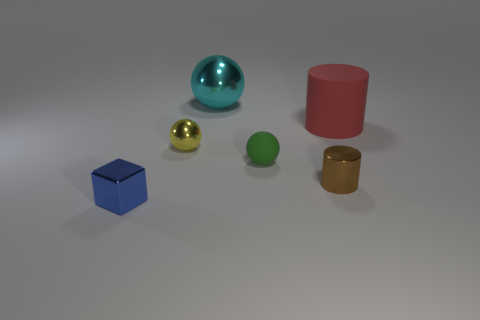What shape is the other rubber object that is the same size as the yellow thing?
Provide a short and direct response. Sphere. Are there any other metallic things of the same shape as the big shiny thing?
Keep it short and to the point. Yes. What material is the green object that is the same size as the yellow thing?
Your answer should be compact. Rubber. There is a tiny brown cylinder; what number of rubber objects are to the right of it?
Offer a terse response. 1. There is a small object that is in front of the brown metallic thing on the right side of the big cyan sphere; what is it made of?
Your answer should be very brief. Metal. Is the brown shiny thing the same size as the green rubber ball?
Make the answer very short. Yes. How many things are either things that are to the right of the small yellow thing or shiny things that are behind the red object?
Your answer should be very brief. 4. Is the number of tiny objects left of the cyan object greater than the number of tiny brown shiny cylinders?
Provide a short and direct response. Yes. What number of other things are there of the same shape as the large red rubber thing?
Give a very brief answer. 1. What material is the object that is to the right of the green ball and behind the tiny cylinder?
Your response must be concise. Rubber. 